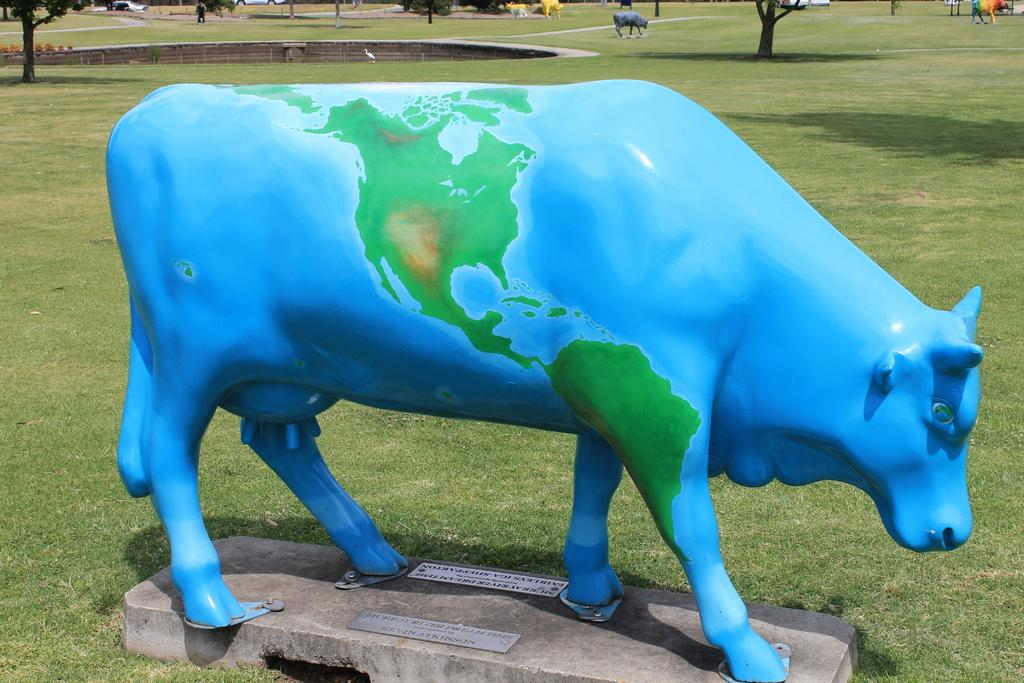What is the color of the statue in the image? The statue in the image is blue. What animal is the statue depicting? The statue is of a cow. What is the immediate environment of the statue? The statue is surrounded by grass. What type of vegetation can be seen in the image? Trees are present in the image. What type of expansion is taking place in the image? There is no indication of any expansion occurring in the image. 